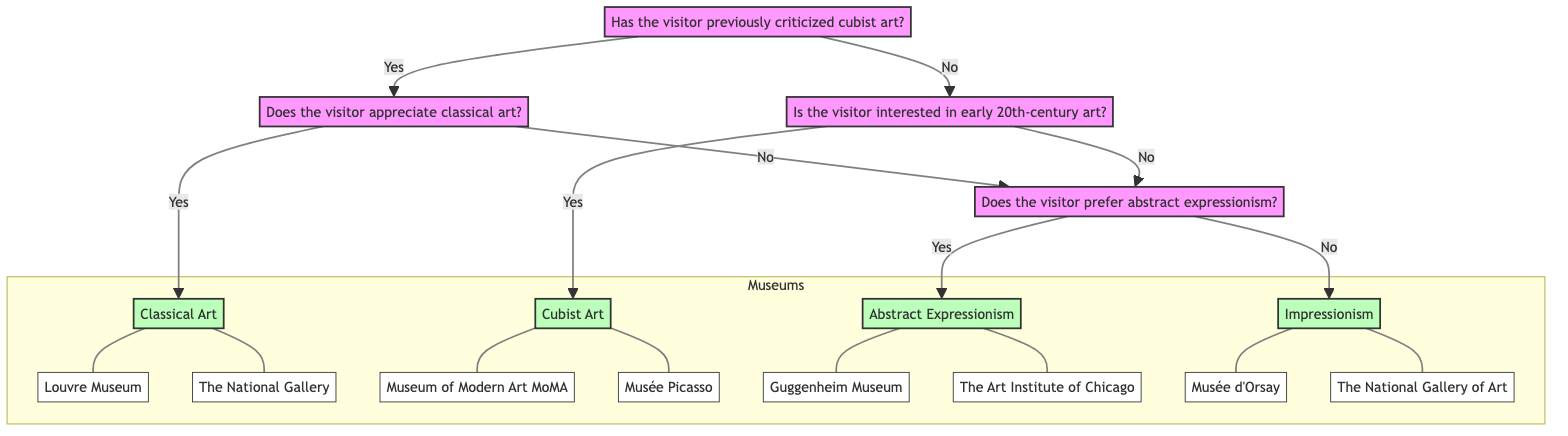Has the visitor previously criticized cubist art? This is the starting question of the diagram. The two possible answers are "Yes" or "No," which lead to different paths in the decision tree.
Answer: Yes or No If the visitor appreciates classical art, what is the recommendation? Following a "Yes" answer to the previous question, the next question confirms if the visitor appreciates classical art. If "Yes," the recommendation is "Classical Art."
Answer: Classical Art What follows after the path where the visitor does not appreciate classical art? The diagram indicates that after a "No" response to appreciating classical art, it leads to another question about abstract expressionism. This is the next step for recommendations.
Answer: Does the visitor prefer abstract expressionism? What is the final recommendation if the visitor prefers abstract expressionism? After confirming that the visitor prefers abstract expressionism, the final recommendation is "Abstract Expressionism."
Answer: Abstract Expressionism What are the examples listed under the recommendation for Impressionism? If the flow from the decision tree concludes with Impressionism, the examples shown are "Musée d'Orsay" and "The National Gallery of Art."
Answer: Musée d'Orsay, The National Gallery of Art How many recommendations are provided in total within the diagram? The diagram indicates four unique recommendations stemming from the various paths: Classical Art, Cubist Art, Abstract Expressionism, and Impressionism.
Answer: Four What museums are associated with the recommendation for Abstract Expressionism? The diagram allows us to observe that the suggestion for Abstract Expressionism includes references to "Guggenheim Museum" and "The Art Institute of Chicago."
Answer: Guggenheim Museum, The Art Institute of Chicago What is the path taken if the visitor has previously criticized cubist art and does not appreciate classical art? Starting from a "Yes" to criticizing cubist art leads to the question about classical art appreciation. A "No" response further leads to questions about abstract expressionism, thereby taking the path of modern art without cubism.
Answer: path_modern 